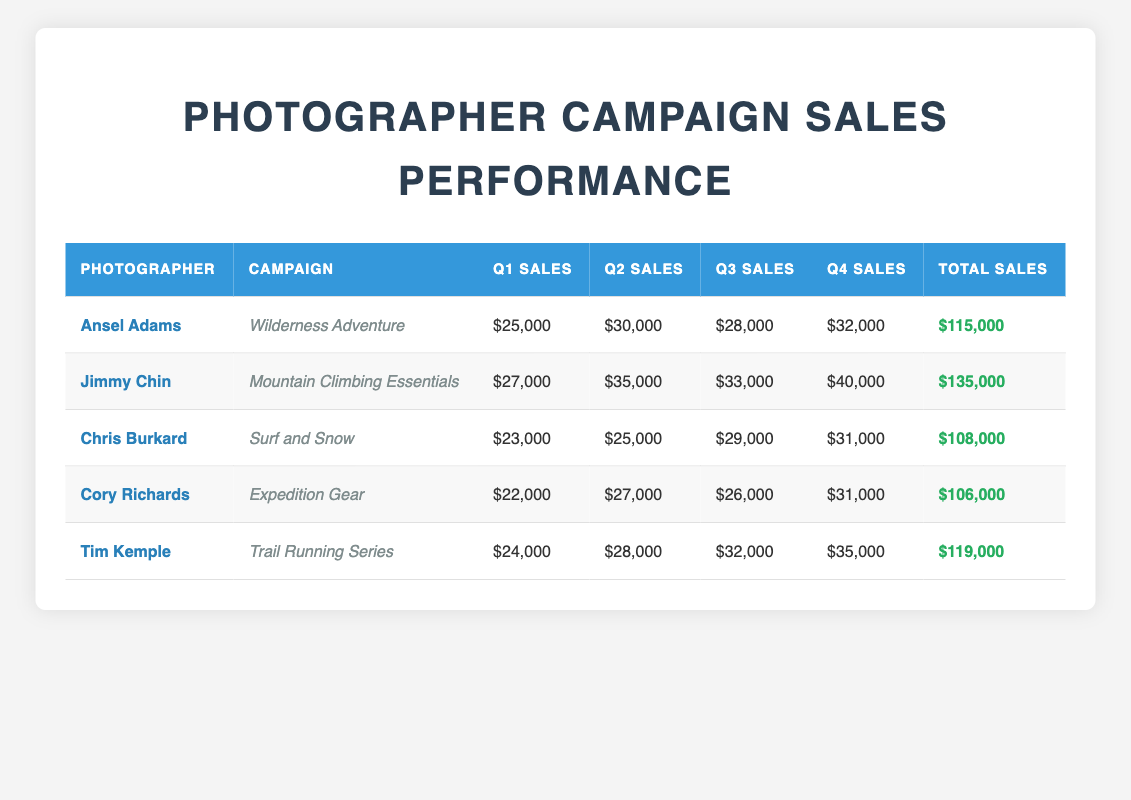What is the total sales amount for Jimmy Chin's campaign? According to the table, the total sales for Jimmy Chin's campaign, "Mountain Climbing Essentials," is listed in the "Total Sales" column as $135,000.
Answer: $135,000 Which campaign had the highest Q4 sales? To find the highest Q4 sales, we look at the Q4 Sales column: Ansel Adams ($32,000), Jimmy Chin ($40,000), Chris Burkard ($31,000), Cory Richards ($31,000), and Tim Kemple ($35,000). The highest value is Jimmy Chin's sales at $40,000.
Answer: Jimmy Chin's campaign What is the average sales for the campaign "Surf and Snow"? For Chris Burkard's "Surf and Snow" campaign, we add the four quarters: (23,000 + 25,000 + 29,000 + 31,000) = 108,000. There are 4 quarters, so we divide: 108,000 / 4 = 27,000.
Answer: 27,000 Is the total sales for Tim Kemple higher than the total sales for Cory Richards? Tim Kemple's total sales are $119,000, while Cory Richards' total sales are $106,000. Comparing these two values, $119,000 is greater than $106,000. Therefore, the answer is yes.
Answer: Yes Which photographer had the lowest sales in Q1? Looking at the Q1 Sales column, Ansel Adams ($25,000), Jimmy Chin ($27,000), Chris Burkard ($23,000), Cory Richards ($22,000), and Tim Kemple ($24,000). Cory Richards has the lowest sales at $22,000.
Answer: Cory Richards What is the total sales difference between Ansel Adams and Chris Burkard? Ansel Adams' total sales are $115,000 and Chris Burkard's total sales are $108,000. The difference is calculated by subtracting Chris Burkard's total from Ansel Adams' total: 115,000 - 108,000 = 7,000.
Answer: 7,000 Did any campaign generate more than $130,000 in total sales? Reviewing the Total Sales column, Jimmy Chin's campaign generated $135,000, which is greater than $130,000. Therefore, the answer is yes.
Answer: Yes Which campaign had the second highest total sales? Arranging the Total Sales amounts in order: 135,000 (Jimmy Chin), 119,000 (Tim Kemple), 115,000 (Ansel Adams), 108,000 (Chris Burkard), and 106,000 (Cory Richards). The second highest is Tim Kemple with $119,000.
Answer: Tim Kemple's campaign What were the total sales in Q3 for all campaigns combined? Adding the Q3 Sales values: 28,000 (Ansel Adams) + 33,000 (Jimmy Chin) + 29,000 (Chris Burkard) + 26,000 (Cory Richards) + 32,000 (Tim Kemple) = 148,000.
Answer: 148,000 